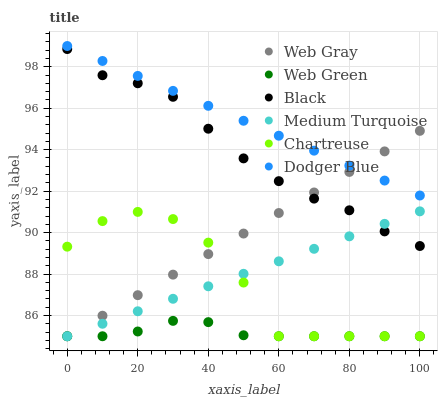Does Web Green have the minimum area under the curve?
Answer yes or no. Yes. Does Dodger Blue have the maximum area under the curve?
Answer yes or no. Yes. Does Chartreuse have the minimum area under the curve?
Answer yes or no. No. Does Chartreuse have the maximum area under the curve?
Answer yes or no. No. Is Dodger Blue the smoothest?
Answer yes or no. Yes. Is Chartreuse the roughest?
Answer yes or no. Yes. Is Web Green the smoothest?
Answer yes or no. No. Is Web Green the roughest?
Answer yes or no. No. Does Web Gray have the lowest value?
Answer yes or no. Yes. Does Dodger Blue have the lowest value?
Answer yes or no. No. Does Dodger Blue have the highest value?
Answer yes or no. Yes. Does Chartreuse have the highest value?
Answer yes or no. No. Is Web Green less than Dodger Blue?
Answer yes or no. Yes. Is Black greater than Chartreuse?
Answer yes or no. Yes. Does Web Green intersect Chartreuse?
Answer yes or no. Yes. Is Web Green less than Chartreuse?
Answer yes or no. No. Is Web Green greater than Chartreuse?
Answer yes or no. No. Does Web Green intersect Dodger Blue?
Answer yes or no. No. 